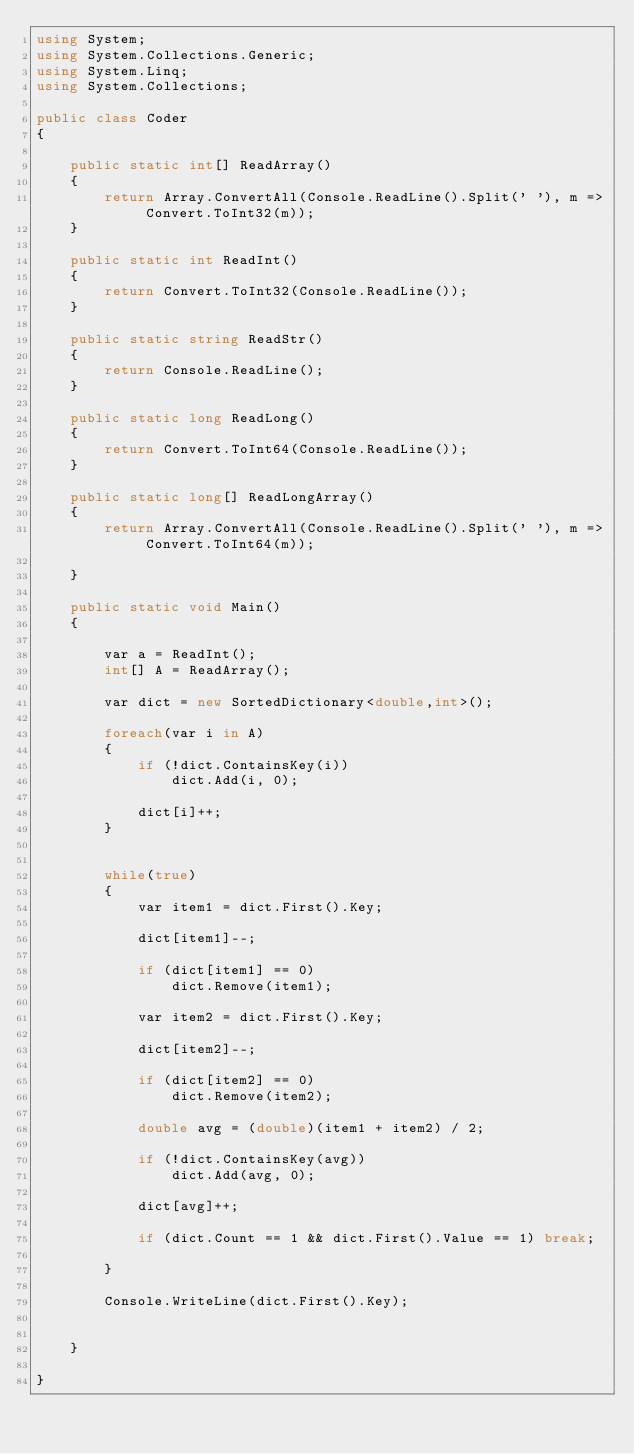Convert code to text. <code><loc_0><loc_0><loc_500><loc_500><_C#_>using System;
using System.Collections.Generic;
using System.Linq;
using System.Collections;
 
public class Coder
{

    public static int[] ReadArray()
    {
        return Array.ConvertAll(Console.ReadLine().Split(' '), m => Convert.ToInt32(m));
    }

    public static int ReadInt()
    {
        return Convert.ToInt32(Console.ReadLine());
    }

    public static string ReadStr()
    {
        return Console.ReadLine();
    }

    public static long ReadLong()
    {
        return Convert.ToInt64(Console.ReadLine());
    }

    public static long[] ReadLongArray()
    {
        return Array.ConvertAll(Console.ReadLine().Split(' '), m => Convert.ToInt64(m));

    }

    public static void Main()
    {

        var a = ReadInt();
        int[] A = ReadArray();

        var dict = new SortedDictionary<double,int>();

        foreach(var i in A)
        {
            if (!dict.ContainsKey(i))
                dict.Add(i, 0);

            dict[i]++;
        }
    

        while(true)
        {
            var item1 = dict.First().Key;

            dict[item1]--;

            if (dict[item1] == 0)
                dict.Remove(item1);

            var item2 = dict.First().Key;

            dict[item2]--;

            if (dict[item2] == 0)
                dict.Remove(item2);

            double avg = (double)(item1 + item2) / 2;

            if (!dict.ContainsKey(avg))
                dict.Add(avg, 0);

            dict[avg]++;

            if (dict.Count == 1 && dict.First().Value == 1) break;

        }

        Console.WriteLine(dict.First().Key);


    }

}
</code> 